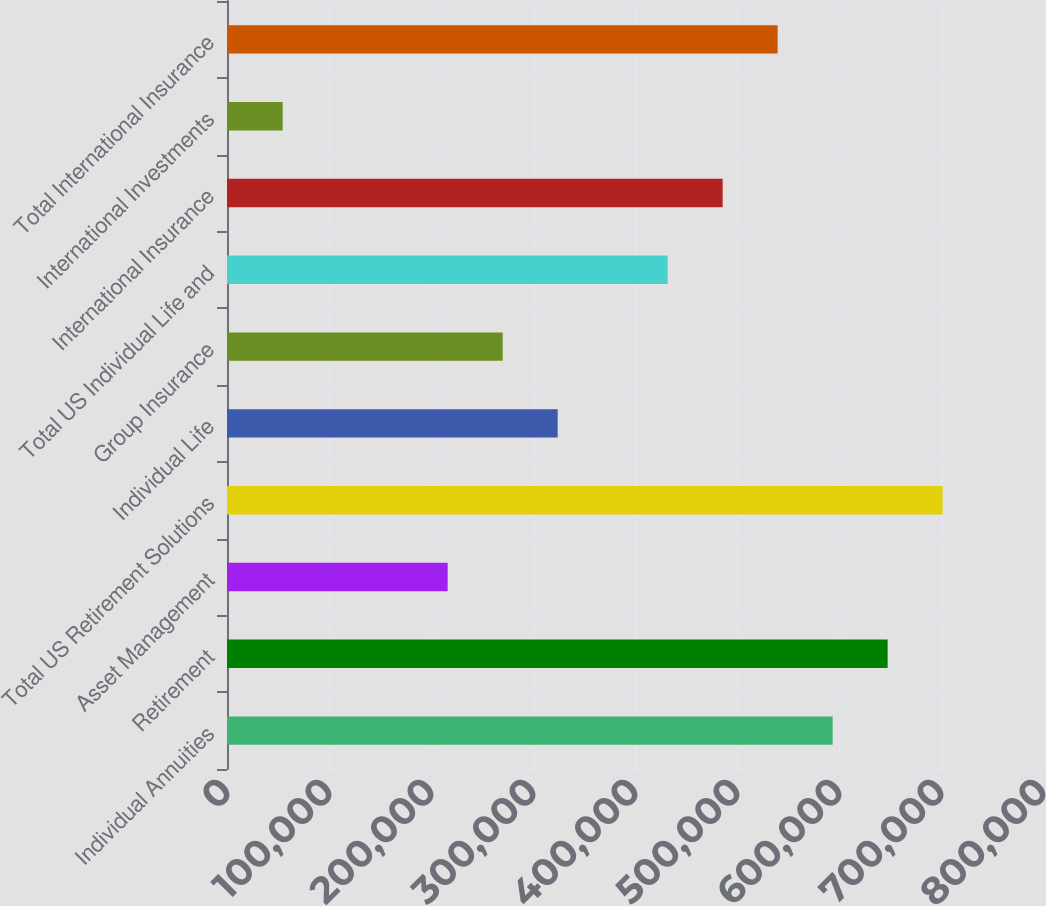Convert chart. <chart><loc_0><loc_0><loc_500><loc_500><bar_chart><fcel>Individual Annuities<fcel>Retirement<fcel>Asset Management<fcel>Total US Retirement Solutions<fcel>Individual Life<fcel>Group Insurance<fcel>Total US Individual Life and<fcel>International Insurance<fcel>International Investments<fcel>Total International Insurance<nl><fcel>593771<fcel>647688<fcel>216353<fcel>701605<fcel>324186<fcel>270270<fcel>432020<fcel>485937<fcel>54601.9<fcel>539854<nl></chart> 